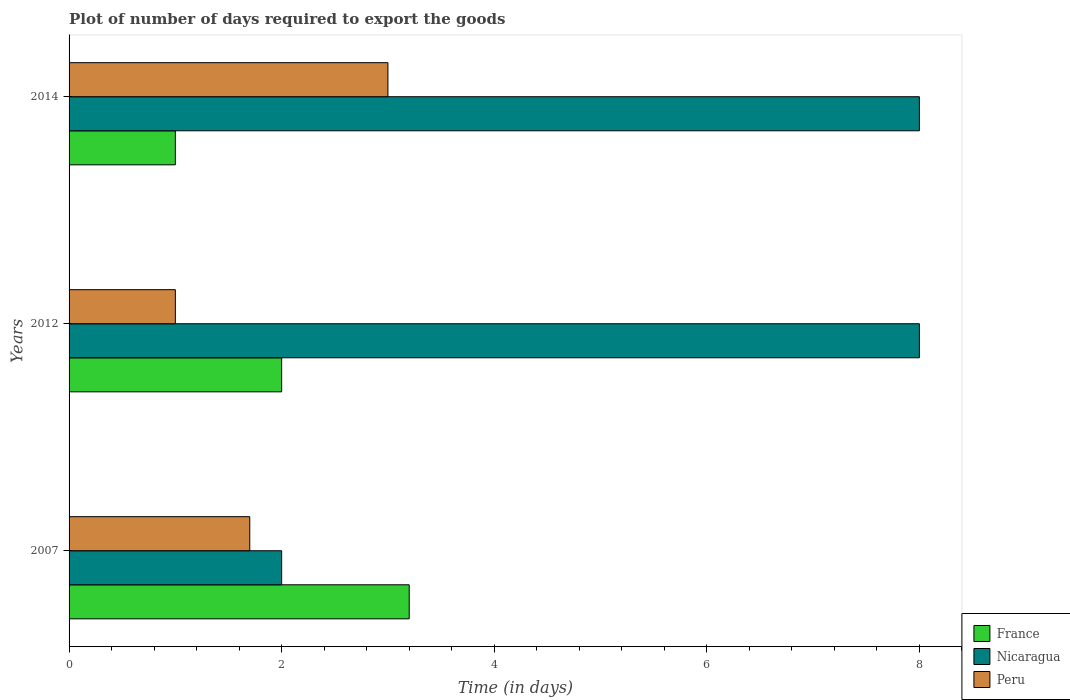Are the number of bars per tick equal to the number of legend labels?
Give a very brief answer. Yes. Are the number of bars on each tick of the Y-axis equal?
Give a very brief answer. Yes. How many bars are there on the 3rd tick from the top?
Provide a succinct answer. 3. How many bars are there on the 1st tick from the bottom?
Offer a very short reply. 3. What is the label of the 2nd group of bars from the top?
Make the answer very short. 2012. In how many cases, is the number of bars for a given year not equal to the number of legend labels?
Ensure brevity in your answer.  0. Across all years, what is the maximum time required to export goods in France?
Your response must be concise. 3.2. Across all years, what is the minimum time required to export goods in Nicaragua?
Give a very brief answer. 2. In which year was the time required to export goods in France minimum?
Provide a succinct answer. 2014. What is the difference between the time required to export goods in Nicaragua in 2014 and the time required to export goods in France in 2007?
Your answer should be very brief. 4.8. In how many years, is the time required to export goods in Peru greater than 6.8 days?
Keep it short and to the point. 0. Is the difference between the time required to export goods in Peru in 2007 and 2012 greater than the difference between the time required to export goods in Nicaragua in 2007 and 2012?
Offer a very short reply. Yes. What is the difference between the highest and the lowest time required to export goods in Peru?
Offer a terse response. 2. In how many years, is the time required to export goods in Nicaragua greater than the average time required to export goods in Nicaragua taken over all years?
Ensure brevity in your answer.  2. Is the sum of the time required to export goods in Peru in 2007 and 2014 greater than the maximum time required to export goods in France across all years?
Provide a short and direct response. Yes. What does the 2nd bar from the top in 2007 represents?
Your response must be concise. Nicaragua. What does the 2nd bar from the bottom in 2014 represents?
Your response must be concise. Nicaragua. How many bars are there?
Make the answer very short. 9. What is the difference between two consecutive major ticks on the X-axis?
Ensure brevity in your answer.  2. Does the graph contain any zero values?
Make the answer very short. No. How many legend labels are there?
Provide a short and direct response. 3. How are the legend labels stacked?
Keep it short and to the point. Vertical. What is the title of the graph?
Offer a terse response. Plot of number of days required to export the goods. What is the label or title of the X-axis?
Ensure brevity in your answer.  Time (in days). What is the Time (in days) of France in 2012?
Your response must be concise. 2. What is the Time (in days) of Peru in 2012?
Give a very brief answer. 1. What is the Time (in days) of France in 2014?
Keep it short and to the point. 1. What is the Time (in days) of Peru in 2014?
Provide a succinct answer. 3. Across all years, what is the maximum Time (in days) of France?
Your answer should be very brief. 3.2. Across all years, what is the maximum Time (in days) of Peru?
Keep it short and to the point. 3. Across all years, what is the minimum Time (in days) of France?
Offer a very short reply. 1. Across all years, what is the minimum Time (in days) in Nicaragua?
Give a very brief answer. 2. Across all years, what is the minimum Time (in days) of Peru?
Ensure brevity in your answer.  1. What is the total Time (in days) of France in the graph?
Your answer should be compact. 6.2. What is the total Time (in days) of Nicaragua in the graph?
Your answer should be very brief. 18. What is the difference between the Time (in days) in France in 2007 and that in 2012?
Make the answer very short. 1.2. What is the difference between the Time (in days) of Nicaragua in 2007 and that in 2012?
Ensure brevity in your answer.  -6. What is the difference between the Time (in days) in Nicaragua in 2007 and that in 2014?
Make the answer very short. -6. What is the difference between the Time (in days) in France in 2012 and that in 2014?
Keep it short and to the point. 1. What is the difference between the Time (in days) of France in 2007 and the Time (in days) of Nicaragua in 2012?
Make the answer very short. -4.8. What is the difference between the Time (in days) of France in 2007 and the Time (in days) of Peru in 2012?
Your response must be concise. 2.2. What is the difference between the Time (in days) in France in 2012 and the Time (in days) in Nicaragua in 2014?
Keep it short and to the point. -6. What is the difference between the Time (in days) in Nicaragua in 2012 and the Time (in days) in Peru in 2014?
Provide a short and direct response. 5. What is the average Time (in days) of France per year?
Offer a terse response. 2.07. What is the average Time (in days) in Peru per year?
Make the answer very short. 1.9. In the year 2007, what is the difference between the Time (in days) in France and Time (in days) in Peru?
Your answer should be very brief. 1.5. In the year 2012, what is the difference between the Time (in days) in France and Time (in days) in Nicaragua?
Offer a very short reply. -6. In the year 2012, what is the difference between the Time (in days) in France and Time (in days) in Peru?
Your answer should be very brief. 1. In the year 2012, what is the difference between the Time (in days) in Nicaragua and Time (in days) in Peru?
Your response must be concise. 7. In the year 2014, what is the difference between the Time (in days) in Nicaragua and Time (in days) in Peru?
Your answer should be compact. 5. What is the ratio of the Time (in days) of France in 2007 to that in 2012?
Ensure brevity in your answer.  1.6. What is the ratio of the Time (in days) of Nicaragua in 2007 to that in 2014?
Keep it short and to the point. 0.25. What is the ratio of the Time (in days) in Peru in 2007 to that in 2014?
Offer a terse response. 0.57. What is the ratio of the Time (in days) of France in 2012 to that in 2014?
Provide a succinct answer. 2. What is the ratio of the Time (in days) in Nicaragua in 2012 to that in 2014?
Make the answer very short. 1. What is the ratio of the Time (in days) of Peru in 2012 to that in 2014?
Keep it short and to the point. 0.33. What is the difference between the highest and the second highest Time (in days) in France?
Give a very brief answer. 1.2. 